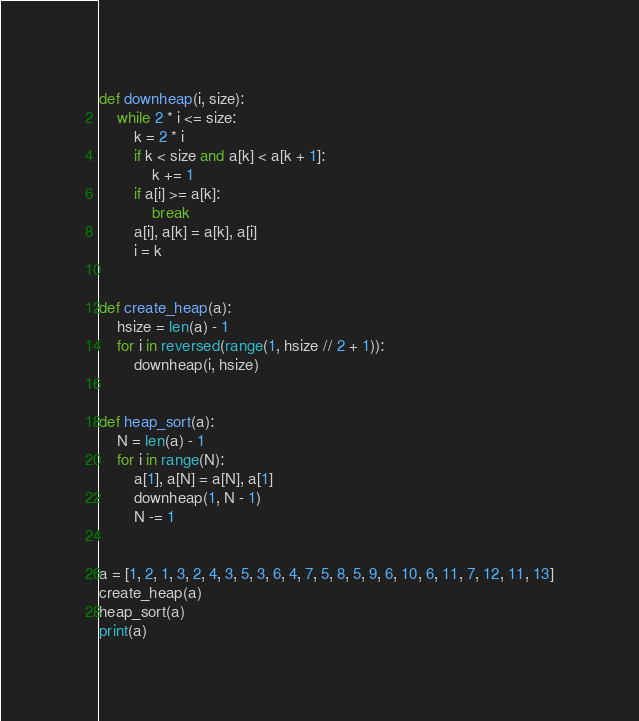Convert code to text. <code><loc_0><loc_0><loc_500><loc_500><_Python_>def downheap(i, size):
    while 2 * i <= size:
        k = 2 * i
        if k < size and a[k] < a[k + 1]:
            k += 1
        if a[i] >= a[k]:
            break
        a[i], a[k] = a[k], a[i]
        i = k


def create_heap(a):
    hsize = len(a) - 1
    for i in reversed(range(1, hsize // 2 + 1)):
        downheap(i, hsize)


def heap_sort(a):
    N = len(a) - 1
    for i in range(N):
        a[1], a[N] = a[N], a[1]
        downheap(1, N - 1)
        N -= 1


a = [1, 2, 1, 3, 2, 4, 3, 5, 3, 6, 4, 7, 5, 8, 5, 9, 6, 10, 6, 11, 7, 12, 11, 13]
create_heap(a)
heap_sort(a)
print(a)</code> 